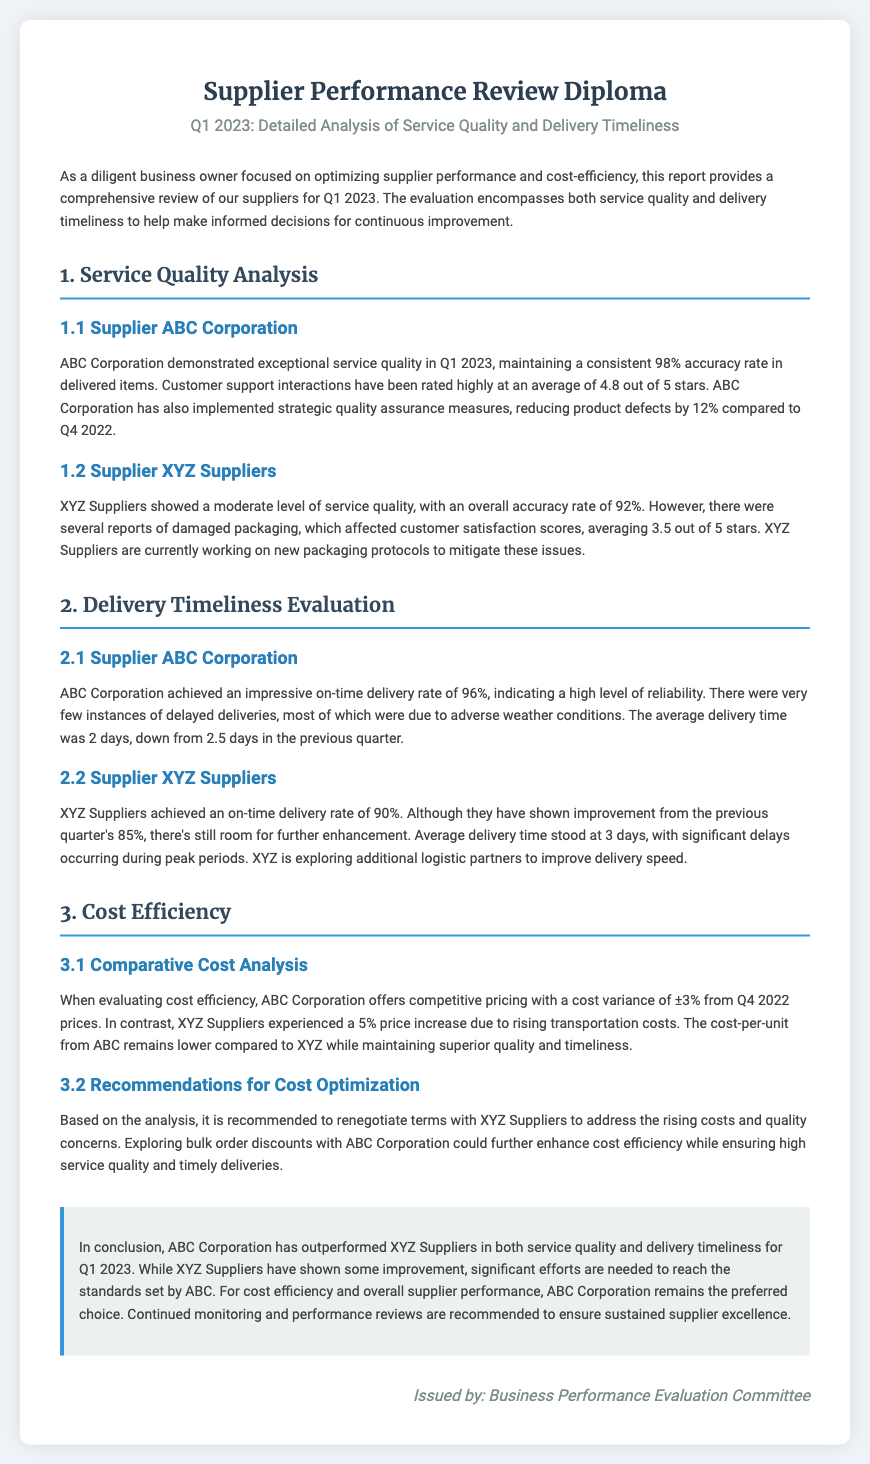What was the accuracy rate for ABC Corporation? The accuracy rate for ABC Corporation is stated as 98%.
Answer: 98% What is the average customer support rating for XYZ Suppliers? The document mentions that XYZ Suppliers have an average customer support rating of 3.5 out of 5 stars.
Answer: 3.5 out of 5 stars What was ABC Corporation's on-time delivery rate? The on-time delivery rate for ABC Corporation is mentioned as 96%.
Answer: 96% What was the average delivery time for XYZ Suppliers? The document provides the average delivery time for XYZ Suppliers as 3 days.
Answer: 3 days What is the cost variance for ABC Corporation? The cost variance for ABC Corporation is stated as ±3% from Q4 2022 prices.
Answer: ±3% Based on the analysis, which supplier is recommended for cost optimization? The document recommends renegotiating terms with XYZ Suppliers for cost optimization.
Answer: XYZ Suppliers What improvement did XYZ Suppliers show in their on-time delivery rate? XYZ Suppliers improved their on-time delivery rate from 85% to 90%.
Answer: 90% Who issued the Supplier Performance Review Diploma? The document was issued by the Business Performance Evaluation Committee.
Answer: Business Performance Evaluation Committee What is the main conclusion about supplier performance in Q1 2023? The conclusion states that ABC Corporation has outperformed XYZ Suppliers in both service quality and delivery timeliness.
Answer: ABC Corporation has outperformed XYZ Suppliers 